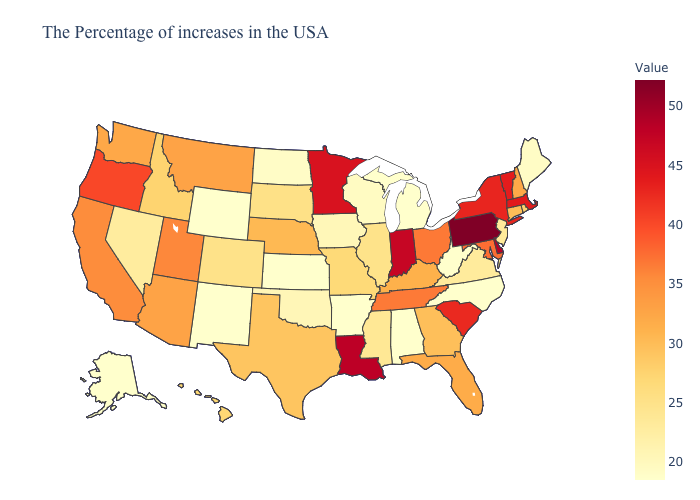Among the states that border Connecticut , does Massachusetts have the lowest value?
Short answer required. No. Among the states that border Minnesota , which have the highest value?
Short answer required. South Dakota. Among the states that border Iowa , which have the highest value?
Give a very brief answer. Minnesota. Does New Mexico have the lowest value in the USA?
Short answer required. Yes. Which states have the highest value in the USA?
Keep it brief. Pennsylvania. Which states have the lowest value in the USA?
Be succinct. North Carolina, West Virginia, Michigan, Alabama, Arkansas, Kansas, Wyoming, New Mexico, Alaska. Does Indiana have the highest value in the MidWest?
Answer briefly. Yes. 